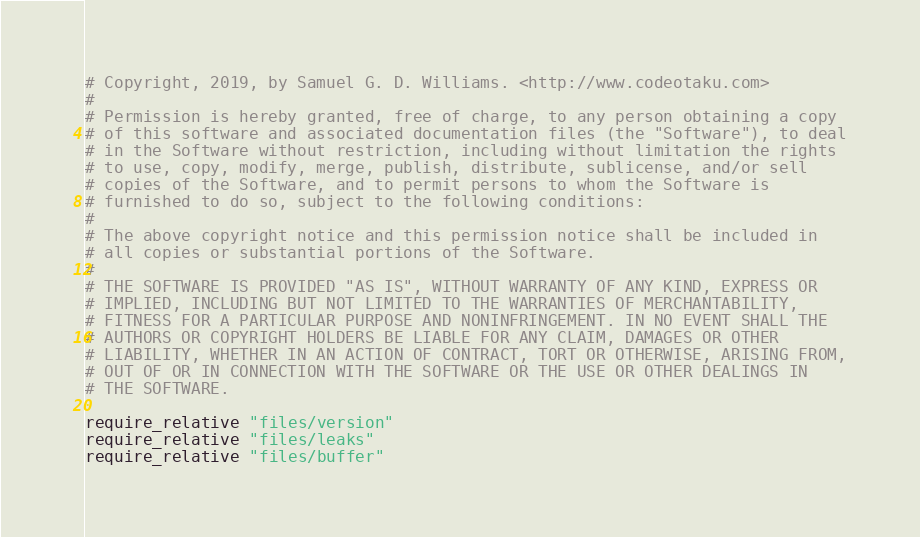Convert code to text. <code><loc_0><loc_0><loc_500><loc_500><_Ruby_># Copyright, 2019, by Samuel G. D. Williams. <http://www.codeotaku.com>
# 
# Permission is hereby granted, free of charge, to any person obtaining a copy
# of this software and associated documentation files (the "Software"), to deal
# in the Software without restriction, including without limitation the rights
# to use, copy, modify, merge, publish, distribute, sublicense, and/or sell
# copies of the Software, and to permit persons to whom the Software is
# furnished to do so, subject to the following conditions:
# 
# The above copyright notice and this permission notice shall be included in
# all copies or substantial portions of the Software.
# 
# THE SOFTWARE IS PROVIDED "AS IS", WITHOUT WARRANTY OF ANY KIND, EXPRESS OR
# IMPLIED, INCLUDING BUT NOT LIMITED TO THE WARRANTIES OF MERCHANTABILITY,
# FITNESS FOR A PARTICULAR PURPOSE AND NONINFRINGEMENT. IN NO EVENT SHALL THE
# AUTHORS OR COPYRIGHT HOLDERS BE LIABLE FOR ANY CLAIM, DAMAGES OR OTHER
# LIABILITY, WHETHER IN AN ACTION OF CONTRACT, TORT OR OTHERWISE, ARISING FROM,
# OUT OF OR IN CONNECTION WITH THE SOFTWARE OR THE USE OR OTHER DEALINGS IN
# THE SOFTWARE.

require_relative "files/version"
require_relative "files/leaks"
require_relative "files/buffer"
</code> 